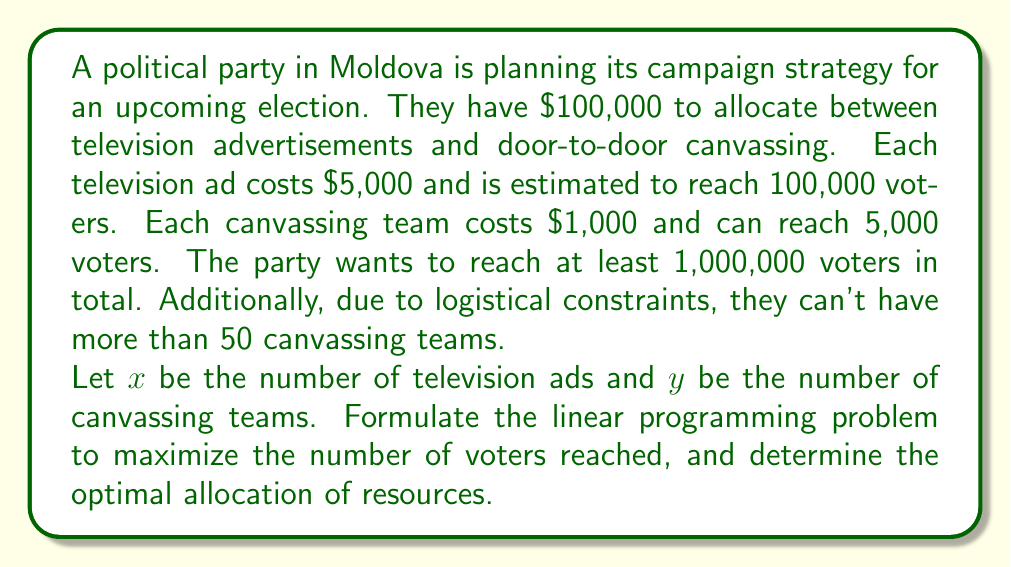Solve this math problem. To solve this problem, we need to set up a linear programming model and then solve it. Let's break it down step by step:

1. Objective function:
   We want to maximize the number of voters reached. Each TV ad reaches 100,000 voters, and each canvassing team reaches 5,000 voters.
   Maximize: $Z = 100000x + 5000y$

2. Constraints:
   a) Budget constraint: $5000x + 1000y \leq 100000$
   b) Minimum voter reach: $100000x + 5000y \geq 1000000$
   c) Maximum canvassing teams: $y \leq 50$
   d) Non-negativity: $x \geq 0, y \geq 0$

3. Solving the linear programming problem:
   We can solve this using the graphical method or the simplex method. Let's use the graphical method for visualization.

   First, let's plot the constraints:
   
   [asy]
   import graph;
   size(200,200);
   
   xaxis("x (TV ads)",0,25);
   yaxis("y (Canvassing teams)",0,60);
   
   draw((0,50)--(20,50),dashed+blue);
   draw((0,100)--(20,0),dashed+red);
   draw((10,0)--(0,50),dashed+green);
   
   label("Budget constraint",(15,25),E,red);
   label("Min voter reach",(5,45),W,green);
   label("Max teams",(18,52),N,blue);
   
   fill((10,0)--(0,50)--(0,50)--(10,50)--(10,0),lightgray);
   
   dot((10,50));
   label("Optimal point",(10,50),NE);
   [/asy]

4. The feasible region is the shaded area. The optimal solution will be at one of the corner points. By inspection or by calculating the objective function value at each corner point, we can determine that the optimal point is at the intersection of the budget constraint and the maximum canvassing teams constraint.

5. To find this point algebraically:
   $5000x + 1000(50) = 100000$
   $5000x = 50000$
   $x = 10$

   So, the optimal solution is $x = 10, y = 50$

6. Checking the minimum voter reach constraint:
   $100000(10) + 5000(50) = 1250000 \geq 1000000$, so this constraint is satisfied.
Answer: The optimal allocation is 10 television ads and 50 canvassing teams, reaching a total of 1,250,000 voters. 